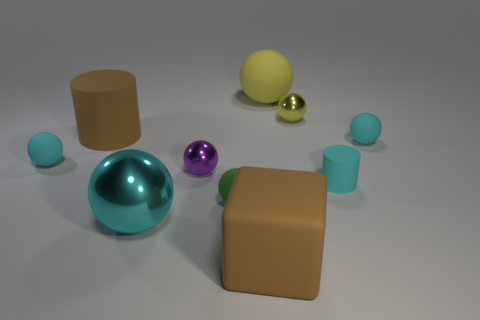Subtract all yellow cylinders. How many cyan balls are left? 3 Subtract all tiny metal spheres. How many spheres are left? 5 Subtract all cyan spheres. How many spheres are left? 4 Subtract all cyan balls. Subtract all red blocks. How many balls are left? 4 Subtract all blocks. How many objects are left? 9 Subtract 0 blue spheres. How many objects are left? 10 Subtract all yellow blocks. Subtract all yellow spheres. How many objects are left? 8 Add 2 rubber balls. How many rubber balls are left? 6 Add 8 green rubber objects. How many green rubber objects exist? 9 